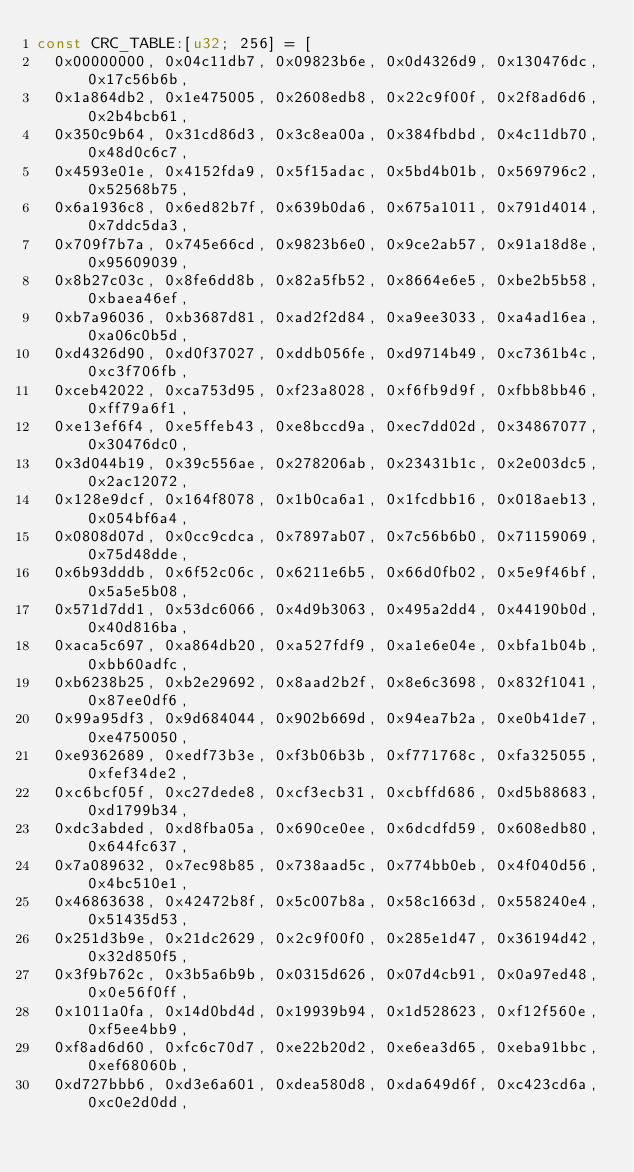Convert code to text. <code><loc_0><loc_0><loc_500><loc_500><_Rust_>const CRC_TABLE:[u32; 256] = [
	0x00000000, 0x04c11db7, 0x09823b6e, 0x0d4326d9, 0x130476dc, 0x17c56b6b,
	0x1a864db2, 0x1e475005, 0x2608edb8, 0x22c9f00f, 0x2f8ad6d6, 0x2b4bcb61,
	0x350c9b64, 0x31cd86d3, 0x3c8ea00a, 0x384fbdbd, 0x4c11db70, 0x48d0c6c7,
	0x4593e01e, 0x4152fda9, 0x5f15adac, 0x5bd4b01b, 0x569796c2, 0x52568b75,
	0x6a1936c8, 0x6ed82b7f, 0x639b0da6, 0x675a1011, 0x791d4014, 0x7ddc5da3,
	0x709f7b7a, 0x745e66cd, 0x9823b6e0, 0x9ce2ab57, 0x91a18d8e, 0x95609039,
	0x8b27c03c, 0x8fe6dd8b, 0x82a5fb52, 0x8664e6e5, 0xbe2b5b58, 0xbaea46ef,
	0xb7a96036, 0xb3687d81, 0xad2f2d84, 0xa9ee3033, 0xa4ad16ea, 0xa06c0b5d,
	0xd4326d90, 0xd0f37027, 0xddb056fe, 0xd9714b49, 0xc7361b4c, 0xc3f706fb,
	0xceb42022, 0xca753d95, 0xf23a8028, 0xf6fb9d9f, 0xfbb8bb46, 0xff79a6f1,
	0xe13ef6f4, 0xe5ffeb43, 0xe8bccd9a, 0xec7dd02d, 0x34867077, 0x30476dc0,
	0x3d044b19, 0x39c556ae, 0x278206ab, 0x23431b1c, 0x2e003dc5, 0x2ac12072,
	0x128e9dcf, 0x164f8078, 0x1b0ca6a1, 0x1fcdbb16, 0x018aeb13, 0x054bf6a4,
	0x0808d07d, 0x0cc9cdca, 0x7897ab07, 0x7c56b6b0, 0x71159069, 0x75d48dde,
	0x6b93dddb, 0x6f52c06c, 0x6211e6b5, 0x66d0fb02, 0x5e9f46bf, 0x5a5e5b08,
	0x571d7dd1, 0x53dc6066, 0x4d9b3063, 0x495a2dd4, 0x44190b0d, 0x40d816ba,
	0xaca5c697, 0xa864db20, 0xa527fdf9, 0xa1e6e04e, 0xbfa1b04b, 0xbb60adfc,
	0xb6238b25, 0xb2e29692, 0x8aad2b2f, 0x8e6c3698, 0x832f1041, 0x87ee0df6,
	0x99a95df3, 0x9d684044, 0x902b669d, 0x94ea7b2a, 0xe0b41de7, 0xe4750050,
	0xe9362689, 0xedf73b3e, 0xf3b06b3b, 0xf771768c, 0xfa325055, 0xfef34de2,
	0xc6bcf05f, 0xc27dede8, 0xcf3ecb31, 0xcbffd686, 0xd5b88683, 0xd1799b34,
	0xdc3abded, 0xd8fba05a, 0x690ce0ee, 0x6dcdfd59, 0x608edb80, 0x644fc637,
	0x7a089632, 0x7ec98b85, 0x738aad5c, 0x774bb0eb, 0x4f040d56, 0x4bc510e1,
	0x46863638, 0x42472b8f, 0x5c007b8a, 0x58c1663d, 0x558240e4, 0x51435d53,
	0x251d3b9e, 0x21dc2629, 0x2c9f00f0, 0x285e1d47, 0x36194d42, 0x32d850f5,
	0x3f9b762c, 0x3b5a6b9b, 0x0315d626, 0x07d4cb91, 0x0a97ed48, 0x0e56f0ff,
	0x1011a0fa, 0x14d0bd4d, 0x19939b94, 0x1d528623, 0xf12f560e, 0xf5ee4bb9,
	0xf8ad6d60, 0xfc6c70d7, 0xe22b20d2, 0xe6ea3d65, 0xeba91bbc, 0xef68060b,
	0xd727bbb6, 0xd3e6a601, 0xdea580d8, 0xda649d6f, 0xc423cd6a, 0xc0e2d0dd,</code> 